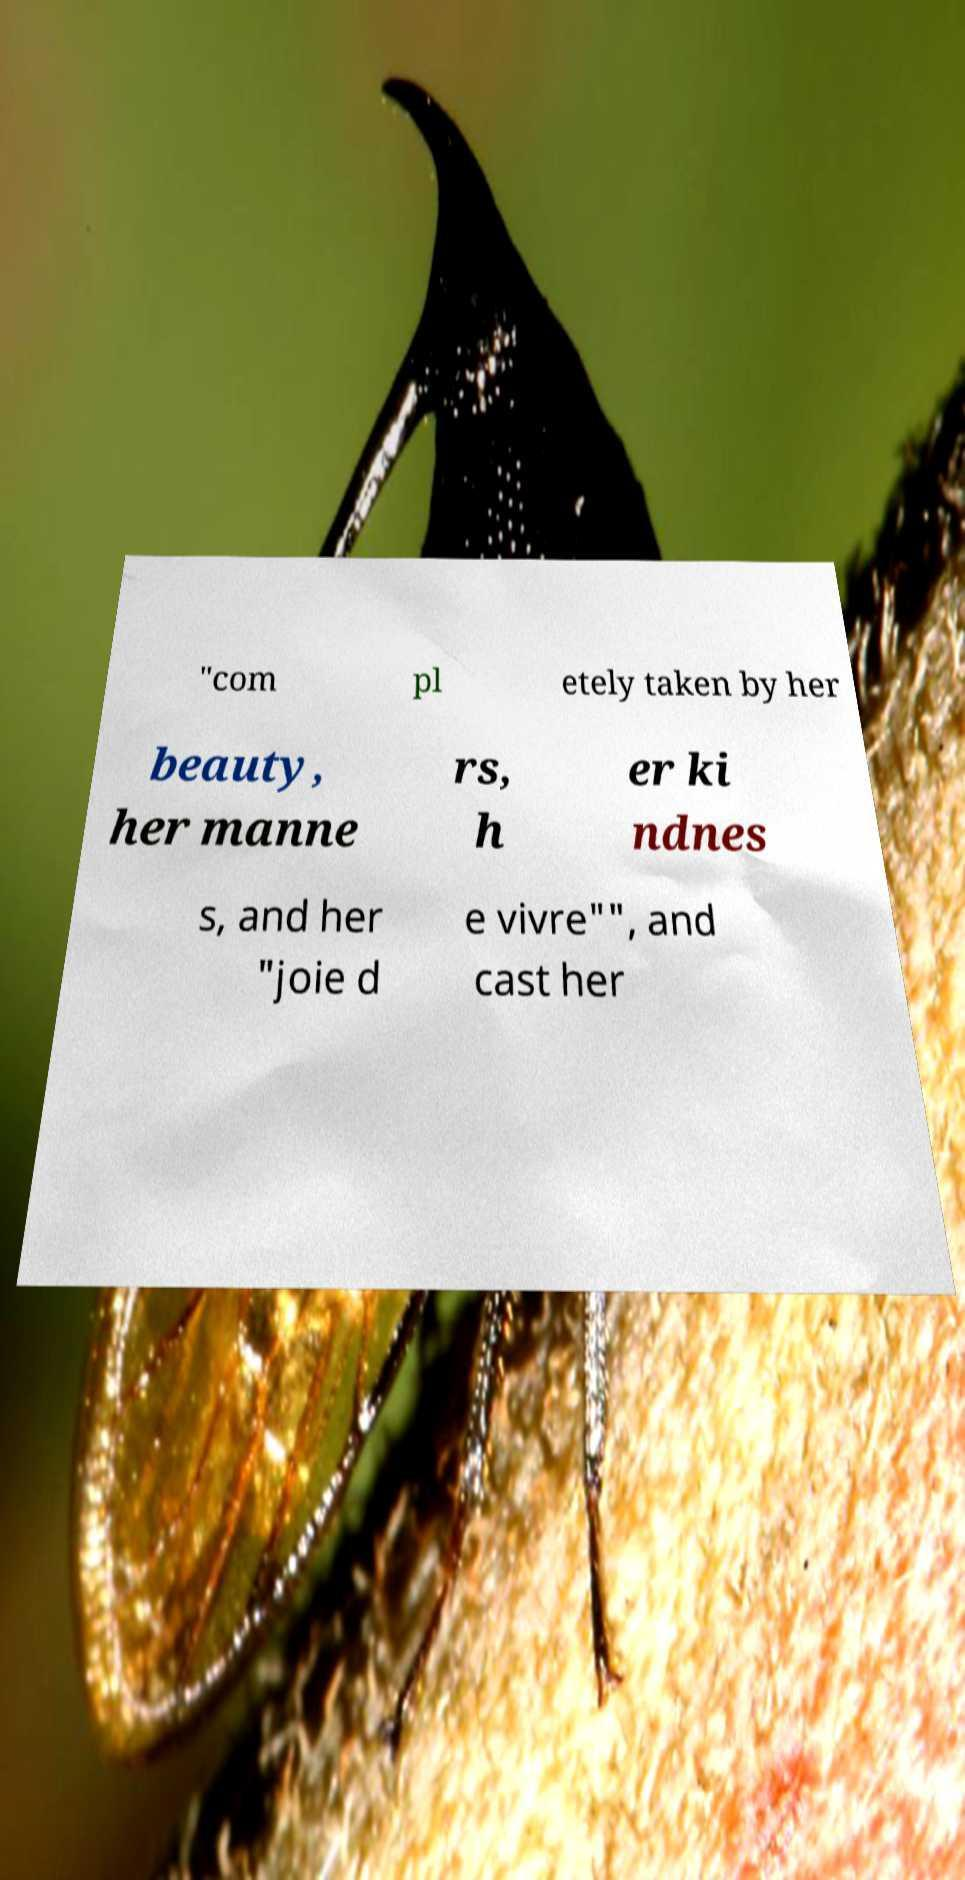Can you read and provide the text displayed in the image?This photo seems to have some interesting text. Can you extract and type it out for me? "com pl etely taken by her beauty, her manne rs, h er ki ndnes s, and her "joie d e vivre"", and cast her 